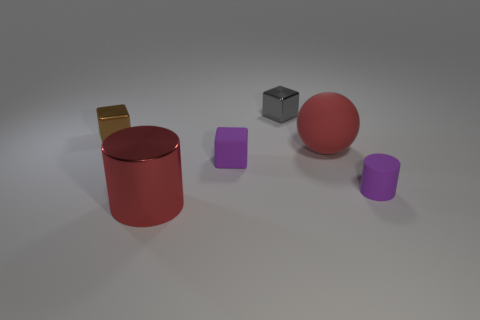Subtract all gray cubes. How many cubes are left? 2 Add 2 tiny purple rubber objects. How many objects exist? 8 Subtract all spheres. How many objects are left? 5 Subtract all yellow cylinders. How many brown blocks are left? 1 Subtract all gray cubes. How many cubes are left? 2 Subtract all brown blocks. Subtract all brown spheres. How many blocks are left? 2 Subtract all gray objects. Subtract all small blue metal cylinders. How many objects are left? 5 Add 2 matte cubes. How many matte cubes are left? 3 Add 1 gray shiny cubes. How many gray shiny cubes exist? 2 Subtract 0 cyan cubes. How many objects are left? 6 